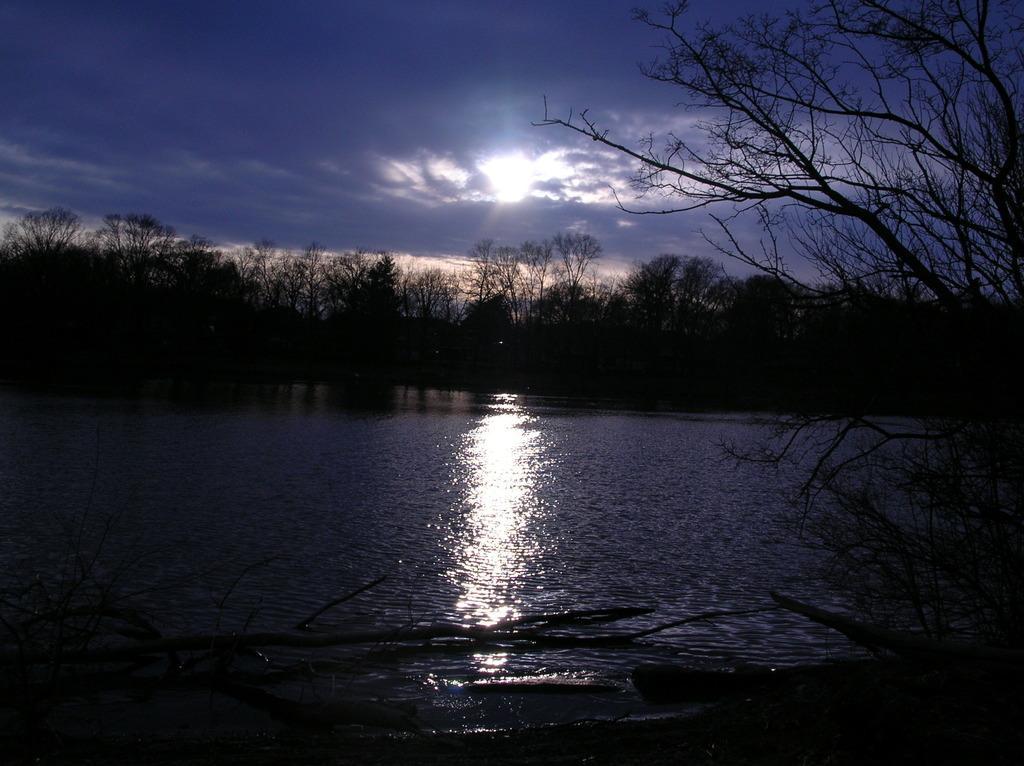In one or two sentences, can you explain what this image depicts? In this picture we can see many trees. On the bottom we can see water or river. On the top we can see sky and clouds. Here it's a sun. 